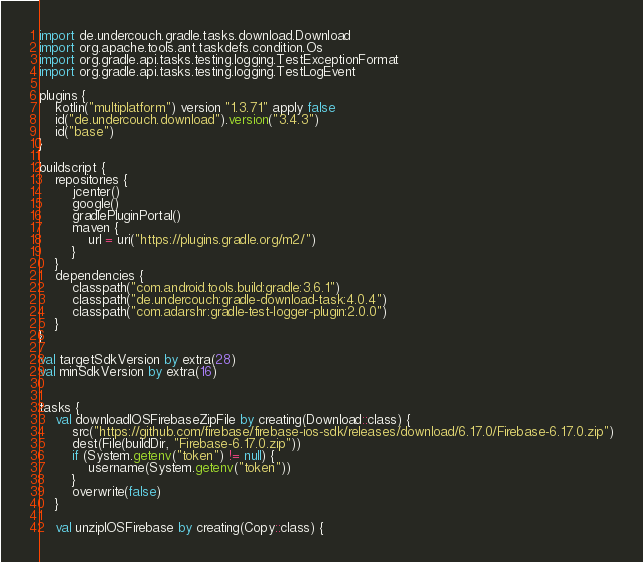Convert code to text. <code><loc_0><loc_0><loc_500><loc_500><_Kotlin_>import de.undercouch.gradle.tasks.download.Download
import org.apache.tools.ant.taskdefs.condition.Os
import org.gradle.api.tasks.testing.logging.TestExceptionFormat
import org.gradle.api.tasks.testing.logging.TestLogEvent

plugins {
    kotlin("multiplatform") version "1.3.71" apply false
    id("de.undercouch.download").version("3.4.3")
    id("base")
}

buildscript {
    repositories {
        jcenter()
        google()
        gradlePluginPortal()
        maven {
            url = uri("https://plugins.gradle.org/m2/")
        }
    }
    dependencies {
        classpath("com.android.tools.build:gradle:3.6.1")
        classpath("de.undercouch:gradle-download-task:4.0.4")
        classpath("com.adarshr:gradle-test-logger-plugin:2.0.0")
    }
}

val targetSdkVersion by extra(28)
val minSdkVersion by extra(16)


tasks {
    val downloadIOSFirebaseZipFile by creating(Download::class) {
        src("https://github.com/firebase/firebase-ios-sdk/releases/download/6.17.0/Firebase-6.17.0.zip")
        dest(File(buildDir, "Firebase-6.17.0.zip"))
        if (System.getenv("token") != null) {
            username(System.getenv("token"))
        }
        overwrite(false)
    }

    val unzipIOSFirebase by creating(Copy::class) {</code> 